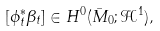Convert formula to latex. <formula><loc_0><loc_0><loc_500><loc_500>[ \phi _ { t } ^ { * } \beta _ { t } ] \in H ^ { 0 } ( \bar { M } _ { 0 } ; \mathcal { H } ^ { 1 } ) ,</formula> 